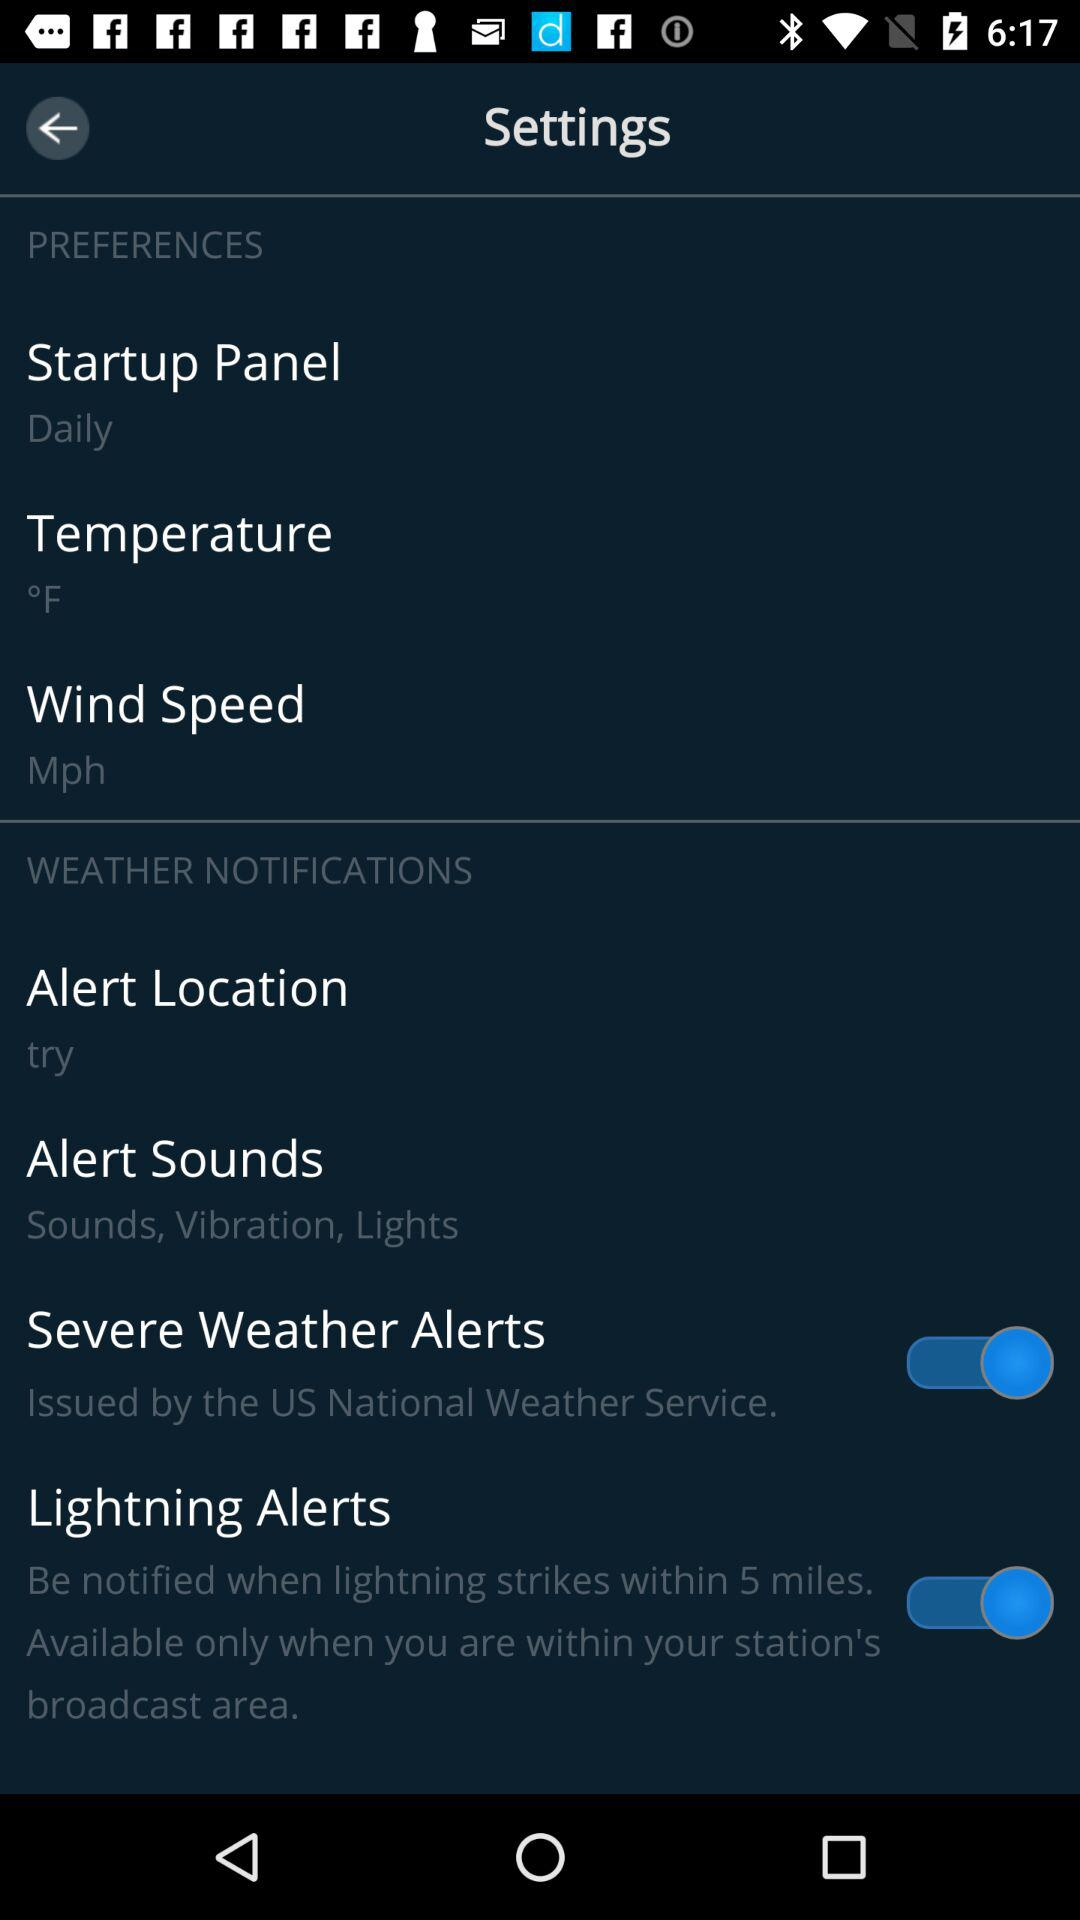What are the user's weather preferences?
When the provided information is insufficient, respond with <no answer>. <no answer> 